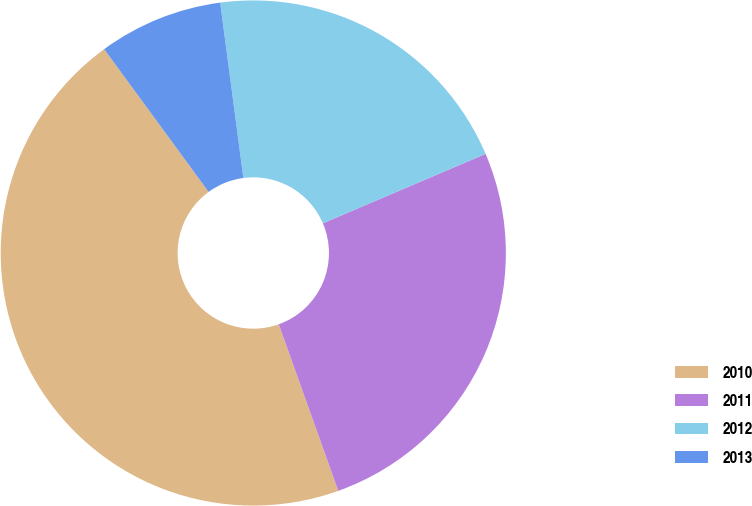Convert chart. <chart><loc_0><loc_0><loc_500><loc_500><pie_chart><fcel>2010<fcel>2011<fcel>2012<fcel>2013<nl><fcel>45.41%<fcel>25.96%<fcel>20.67%<fcel>7.96%<nl></chart> 